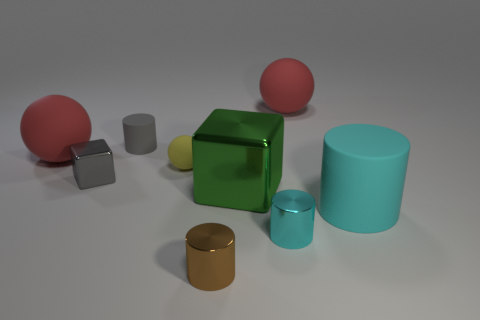There is a tiny thing that is the same color as the tiny shiny block; what is its shape?
Your answer should be very brief. Cylinder. There is a tiny gray block; what number of gray shiny objects are to the left of it?
Give a very brief answer. 0. Is the shape of the big cyan object the same as the yellow rubber object?
Your answer should be very brief. No. What number of cylinders are in front of the big cyan matte object and left of the brown object?
Provide a short and direct response. 0. What number of things are either big blocks or tiny things that are to the right of the tiny cube?
Offer a very short reply. 5. Are there more big red objects than large brown matte cubes?
Your answer should be very brief. Yes. What shape is the big matte object that is to the left of the tiny brown object?
Offer a very short reply. Sphere. What number of other cyan objects have the same shape as the cyan matte thing?
Offer a very short reply. 1. There is a cyan cylinder right of the rubber ball that is right of the tiny yellow matte object; what size is it?
Keep it short and to the point. Large. What number of gray things are either large balls or cubes?
Your response must be concise. 1. 